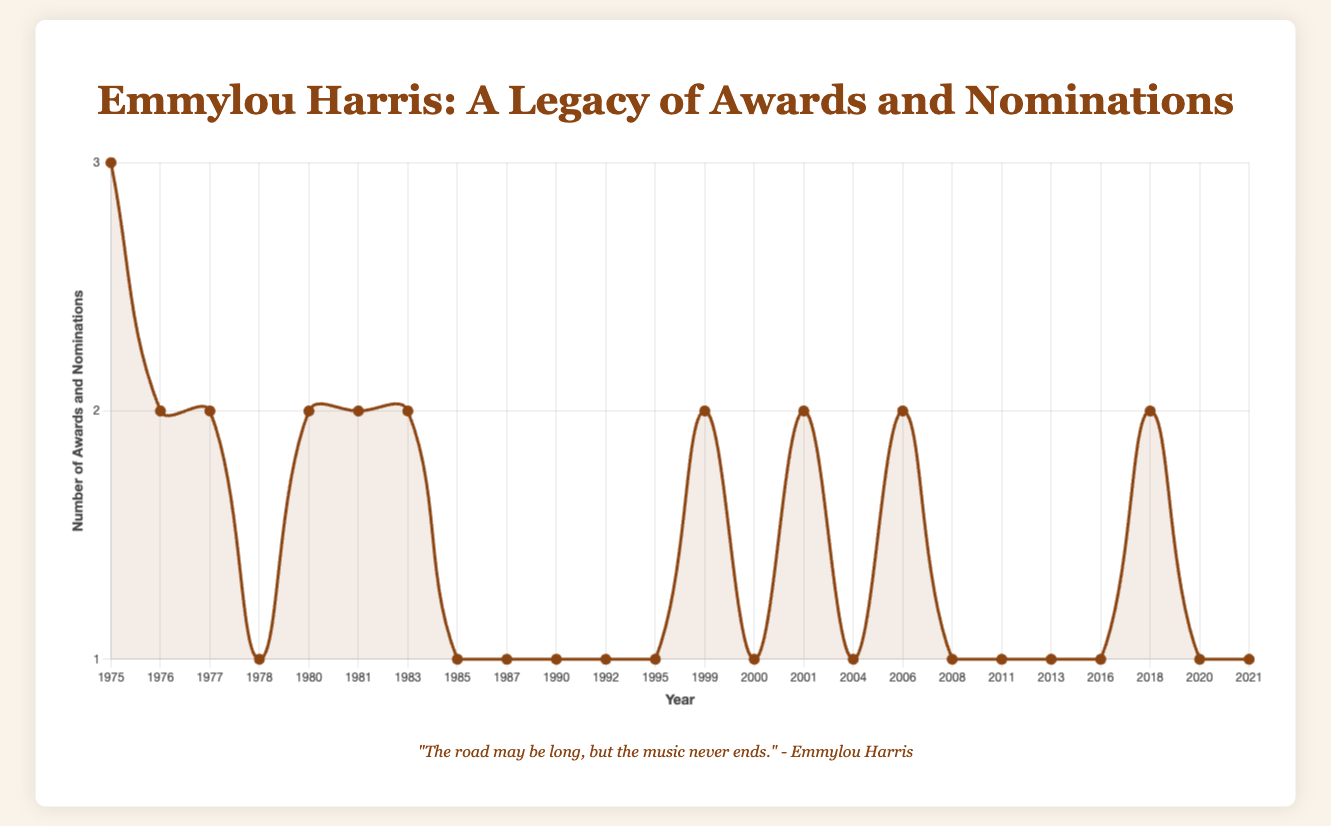What year did Emmylou Harris receive the most awards and nominations? In the figure, identify the highest peak on the curve and note the associated year on the x-axis, which indicates the year with the most awards and nominations.
Answer: 1975 How many awards and nominations did Emmylou Harris receive in 1983? Locate the data point for the year 1983 on the curve, then refer to the pop-up details or legend showing the total count for that year.
Answer: 2 What is the trend of awards and nominations from 1980 to 1985? Observe the data points from 1980 to 1985 on the x-axis for the trend. Identify whether the line ascends, descends, or fluctuates.
Answer: Fluctuates How many awards and nominations did Emmylou Harris receive from 2000 to 2020? Sum the values represented at each data point between the years 2000 and 2020 from the curve. Add each individual year's count to get the total.
Answer: 13 Between which years did Emmylou Harris receive the award for "Female Vocalist of the Year"? Identify the years where "Female Vocalist of the Year" is mentioned in the pop-up details of the data points on the curve.
Answer: 1975, 1976, 1978, 1983, 1987, 1999, 2001, 2013, 2021 Compare Emmylou Harris's awards and nominations in 1990 and 1999. Which year had more? Identify the data points for both years (1990 and 1999) on the curve and compare the total count of awards and nominations represented by each point.
Answer: 1999 What is the difference in the total number of awards and nominations received by Emmylou Harris between the year 2004 and 2008? Identify the data points for 2004 and 2008 on the curve. Subtract the 2004 total from the 2008 total to find the difference.
Answer: 0 What is the average number of awards and nominations per year from 1975 to 2021? Sum all the awards and nominations from each year and divide the total by the number of years, which is the length of the array from 1975 to 2021 (23 years).
Answer: 1.3 How does the number of awards and nominations in 2018 compare to those in 1977? Locate the data points for 2018 and 1977 on the curve, and compare the totals represented by each point.
Answer: Equal What is the overall trend in Emmylou Harris's awards and nominations over time? Observe the general movement of the curve from 1975 to 2021, noting if it generally rises, falls, or has fluctuations.
Answer: Fluctuates 